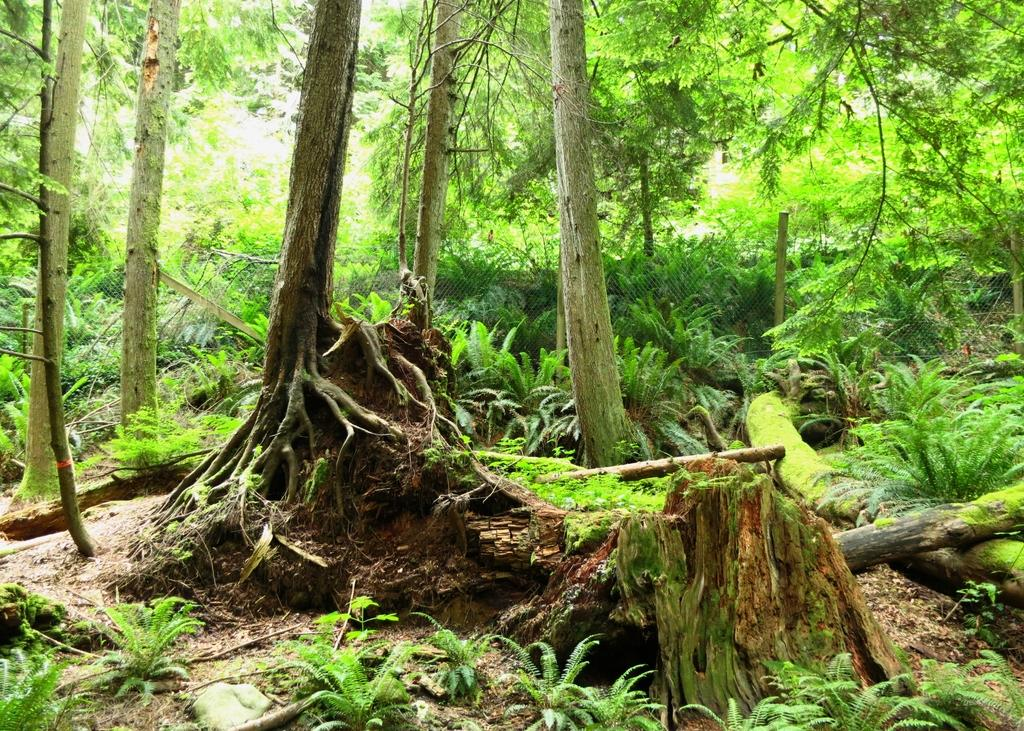What type of vegetation can be seen in the image? There are trees and plants in the image. Can you describe the mesh in the image? Yes, there is a mesh in the image. What type of government is depicted in the image? There is no government depicted in the image; it features trees, plants, and a mesh. What time of day is it in the image? The time of day is not mentioned in the image, so it cannot be determined. 